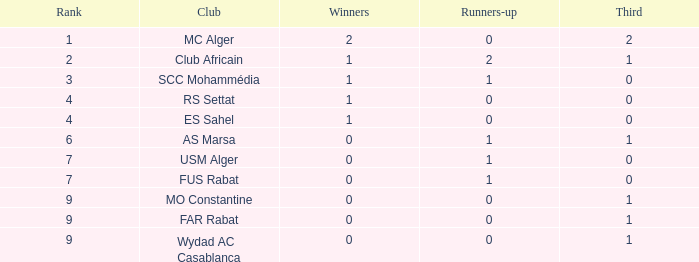Which winners is the supreme one having a rank above 7 and a third smaller than 1? None. 